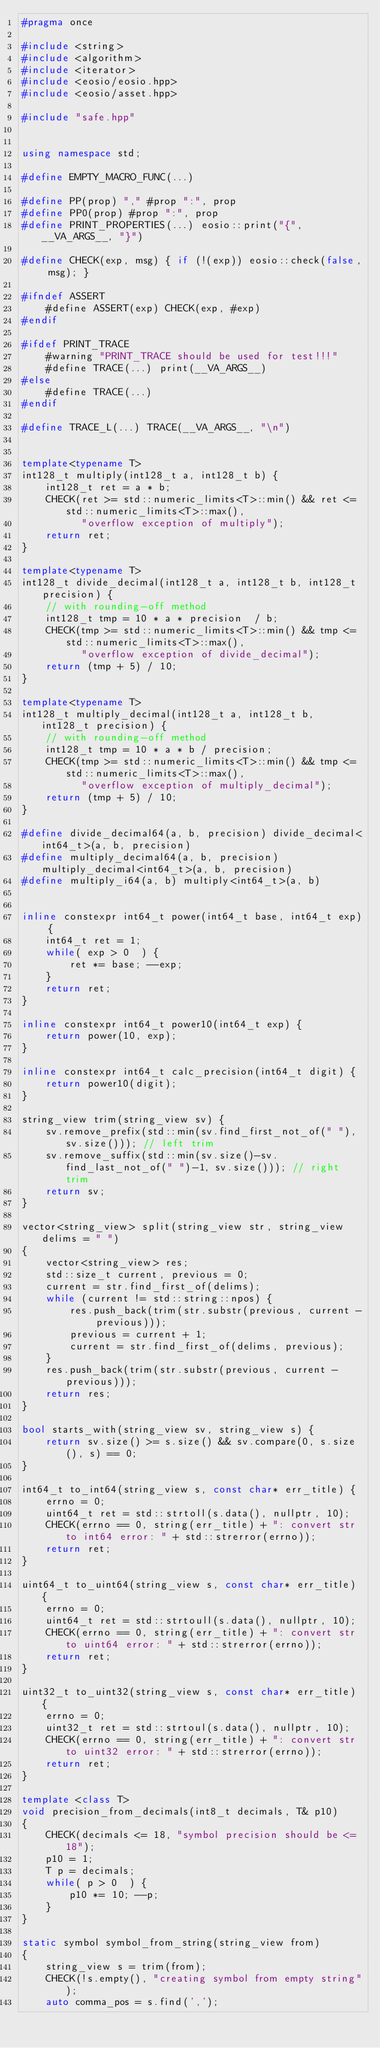<code> <loc_0><loc_0><loc_500><loc_500><_C++_>#pragma once

#include <string>
#include <algorithm>
#include <iterator>
#include <eosio/eosio.hpp>
#include <eosio/asset.hpp>

#include "safe.hpp"


using namespace std;

#define EMPTY_MACRO_FUNC(...)

#define PP(prop) "," #prop ":", prop
#define PP0(prop) #prop ":", prop
#define PRINT_PROPERTIES(...) eosio::print("{", __VA_ARGS__, "}")

#define CHECK(exp, msg) { if (!(exp)) eosio::check(false, msg); }

#ifndef ASSERT
    #define ASSERT(exp) CHECK(exp, #exp)
#endif

#ifdef PRINT_TRACE
    #warning "PRINT_TRACE should be used for test!!!"
    #define TRACE(...) print(__VA_ARGS__)
#else
    #define TRACE(...)
#endif

#define TRACE_L(...) TRACE(__VA_ARGS__, "\n")


template<typename T>
int128_t multiply(int128_t a, int128_t b) {
    int128_t ret = a * b;
    CHECK(ret >= std::numeric_limits<T>::min() && ret <= std::numeric_limits<T>::max(),
          "overflow exception of multiply");
    return ret;
}

template<typename T>
int128_t divide_decimal(int128_t a, int128_t b, int128_t precision) {
    // with rounding-off method
    int128_t tmp = 10 * a * precision  / b;
    CHECK(tmp >= std::numeric_limits<T>::min() && tmp <= std::numeric_limits<T>::max(),
          "overflow exception of divide_decimal");
    return (tmp + 5) / 10;
}

template<typename T>
int128_t multiply_decimal(int128_t a, int128_t b, int128_t precision) {
    // with rounding-off method
    int128_t tmp = 10 * a * b / precision;
    CHECK(tmp >= std::numeric_limits<T>::min() && tmp <= std::numeric_limits<T>::max(),
          "overflow exception of multiply_decimal");
    return (tmp + 5) / 10;
}

#define divide_decimal64(a, b, precision) divide_decimal<int64_t>(a, b, precision)
#define multiply_decimal64(a, b, precision) multiply_decimal<int64_t>(a, b, precision)
#define multiply_i64(a, b) multiply<int64_t>(a, b)


inline constexpr int64_t power(int64_t base, int64_t exp) {
    int64_t ret = 1;
    while( exp > 0  ) {
        ret *= base; --exp;
    }
    return ret;
}

inline constexpr int64_t power10(int64_t exp) {
    return power(10, exp);
}

inline constexpr int64_t calc_precision(int64_t digit) {
    return power10(digit);
}

string_view trim(string_view sv) {
    sv.remove_prefix(std::min(sv.find_first_not_of(" "), sv.size())); // left trim
    sv.remove_suffix(std::min(sv.size()-sv.find_last_not_of(" ")-1, sv.size())); // right trim
    return sv;
}

vector<string_view> split(string_view str, string_view delims = " ")
{
    vector<string_view> res;
    std::size_t current, previous = 0;
    current = str.find_first_of(delims);
    while (current != std::string::npos) {
        res.push_back(trim(str.substr(previous, current - previous)));
        previous = current + 1;
        current = str.find_first_of(delims, previous);
    }
    res.push_back(trim(str.substr(previous, current - previous)));
    return res;
}

bool starts_with(string_view sv, string_view s) {
    return sv.size() >= s.size() && sv.compare(0, s.size(), s) == 0;
}

int64_t to_int64(string_view s, const char* err_title) {
    errno = 0;
    uint64_t ret = std::strtoll(s.data(), nullptr, 10);
    CHECK(errno == 0, string(err_title) + ": convert str to int64 error: " + std::strerror(errno));
    return ret;
}

uint64_t to_uint64(string_view s, const char* err_title) {
    errno = 0;
    uint64_t ret = std::strtoull(s.data(), nullptr, 10);
    CHECK(errno == 0, string(err_title) + ": convert str to uint64 error: " + std::strerror(errno));
    return ret;
}

uint32_t to_uint32(string_view s, const char* err_title) {
    errno = 0;
    uint32_t ret = std::strtoul(s.data(), nullptr, 10);
    CHECK(errno == 0, string(err_title) + ": convert str to uint32 error: " + std::strerror(errno));
    return ret;
}

template <class T>
void precision_from_decimals(int8_t decimals, T& p10)
{
    CHECK(decimals <= 18, "symbol precision should be <= 18");
    p10 = 1;
    T p = decimals;
    while( p > 0  ) {
        p10 *= 10; --p;
    }
}

static symbol symbol_from_string(string_view from)
{
    string_view s = trim(from);
    CHECK(!s.empty(), "creating symbol from empty string");
    auto comma_pos = s.find(',');</code> 